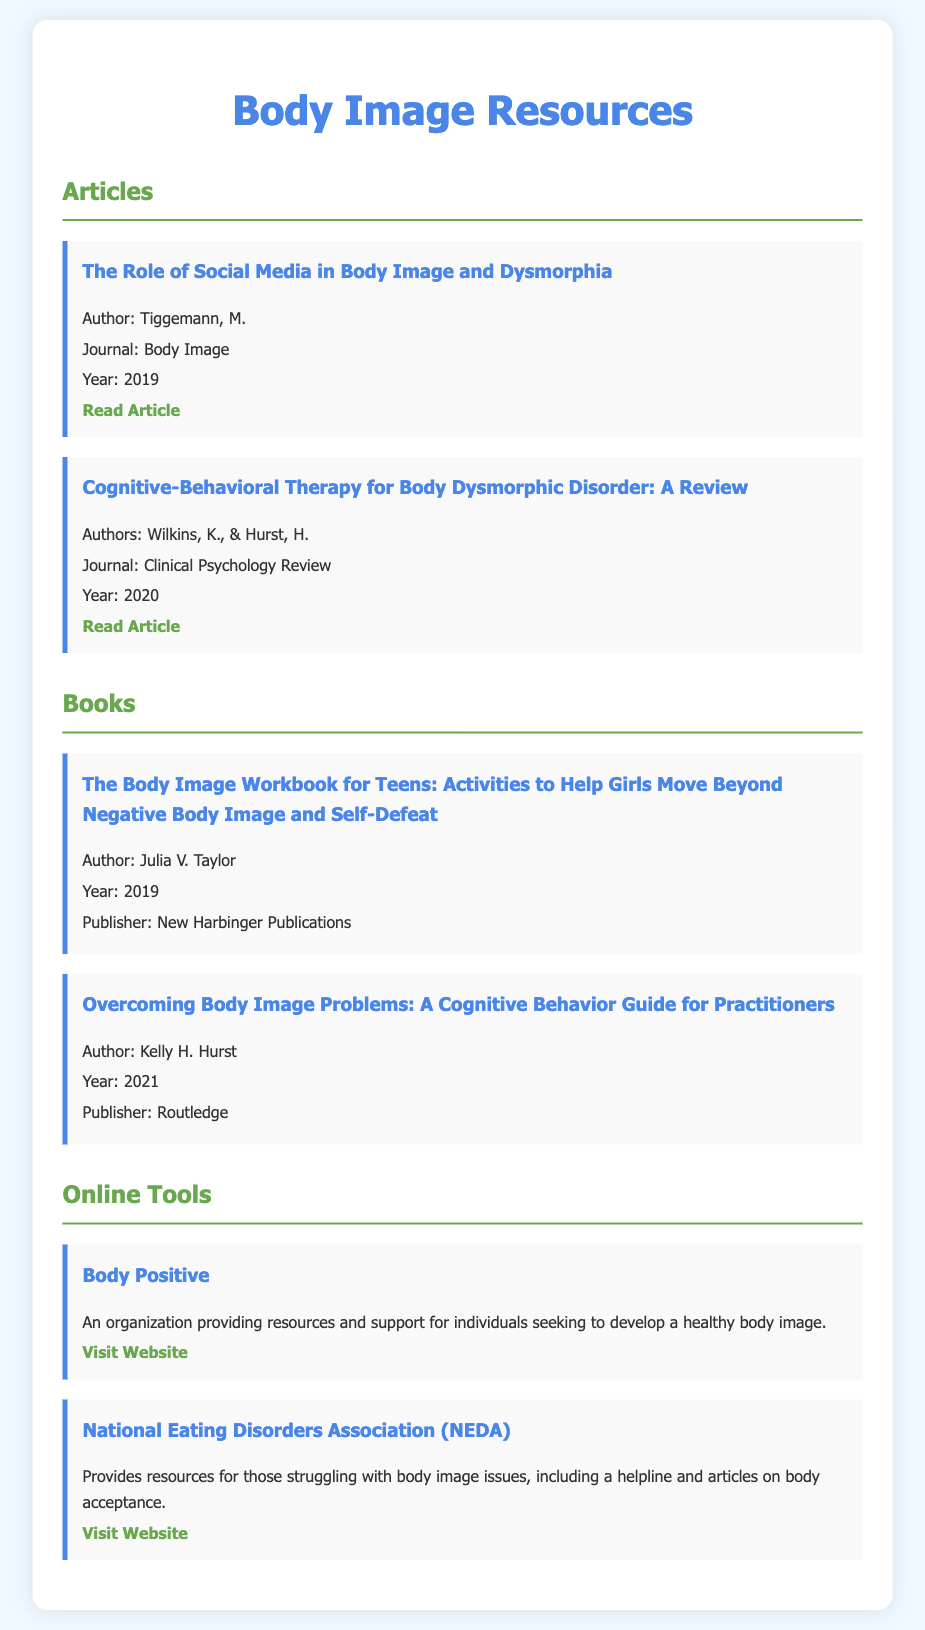What is the title of the first article listed? The title of the first article listed is the one found under "Articles," which is specifically mentioned.
Answer: The Role of Social Media in Body Image and Dysmorphia Who is the author of the book "Overcoming Body Image Problems"? The author's name is found in the list of books in the document.
Answer: Kelly H. Hurst What year was "The Body Image Workbook for Teens" published? The publication year is provided in the details of the book within the document.
Answer: 2019 Which organization focuses on developing a healthy body image? This organization is listed under "Online Tools" and aims to support individuals.
Answer: Body Positive How many articles are listed in the document? The number of articles can be counted from the "Articles" section in the document.
Answer: 2 What is the publisher of "Overcoming Body Image Problems"? The publisher is mentioned in the details of the book section in the document.
Answer: Routledge What journal published the article "Cognitive-Behavioral Therapy for Body Dysmorphic Disorder: A Review"? The name of the journal is specified in the document's article details.
Answer: Clinical Psychology Review What type of resources does the National Eating Disorders Association provide? The type of resources is included in the description of the organization.
Answer: Helpline and articles on body acceptance 